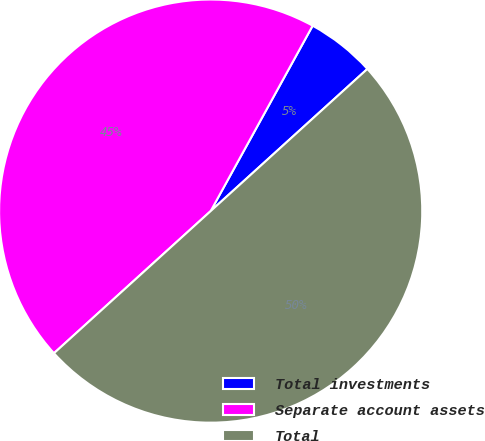Convert chart to OTSL. <chart><loc_0><loc_0><loc_500><loc_500><pie_chart><fcel>Total investments<fcel>Separate account assets<fcel>Total<nl><fcel>5.27%<fcel>44.73%<fcel>50.0%<nl></chart> 